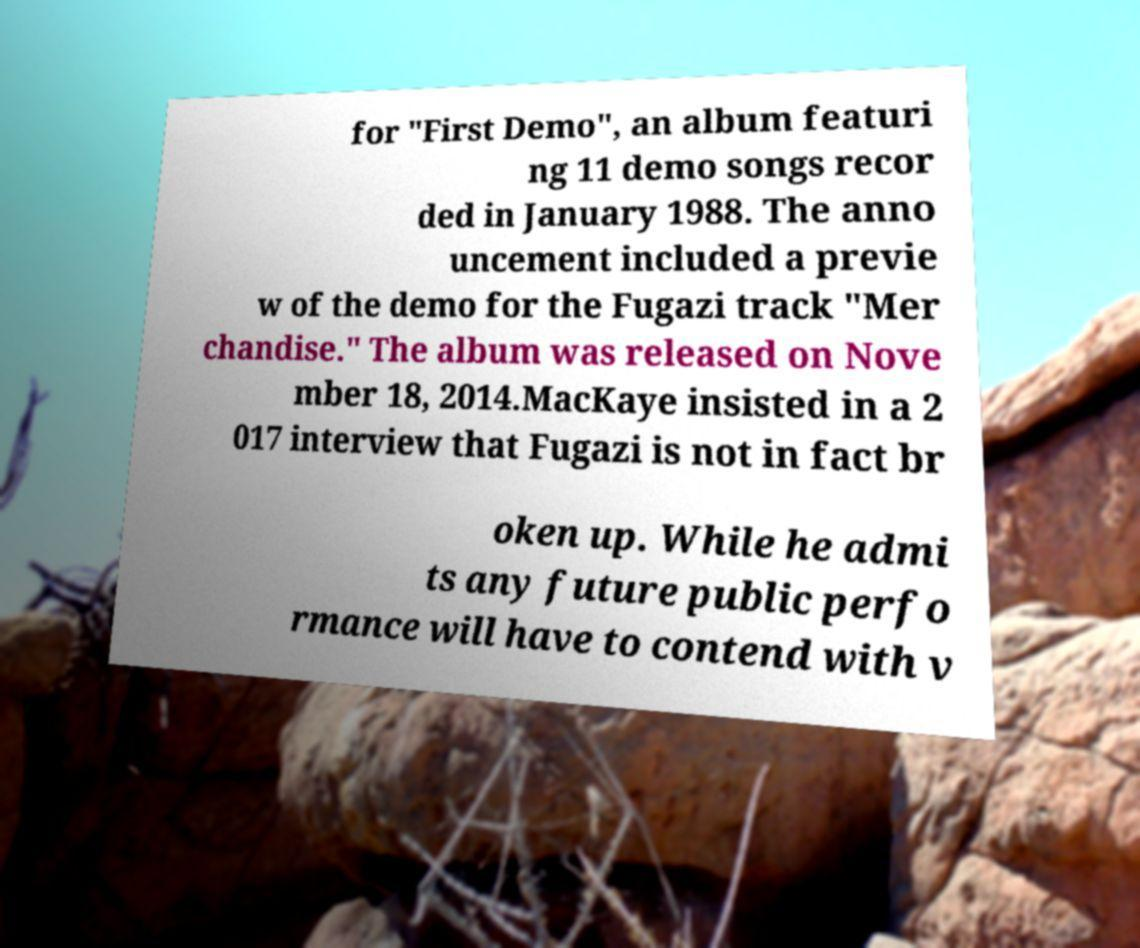I need the written content from this picture converted into text. Can you do that? for "First Demo", an album featuri ng 11 demo songs recor ded in January 1988. The anno uncement included a previe w of the demo for the Fugazi track "Mer chandise." The album was released on Nove mber 18, 2014.MacKaye insisted in a 2 017 interview that Fugazi is not in fact br oken up. While he admi ts any future public perfo rmance will have to contend with v 